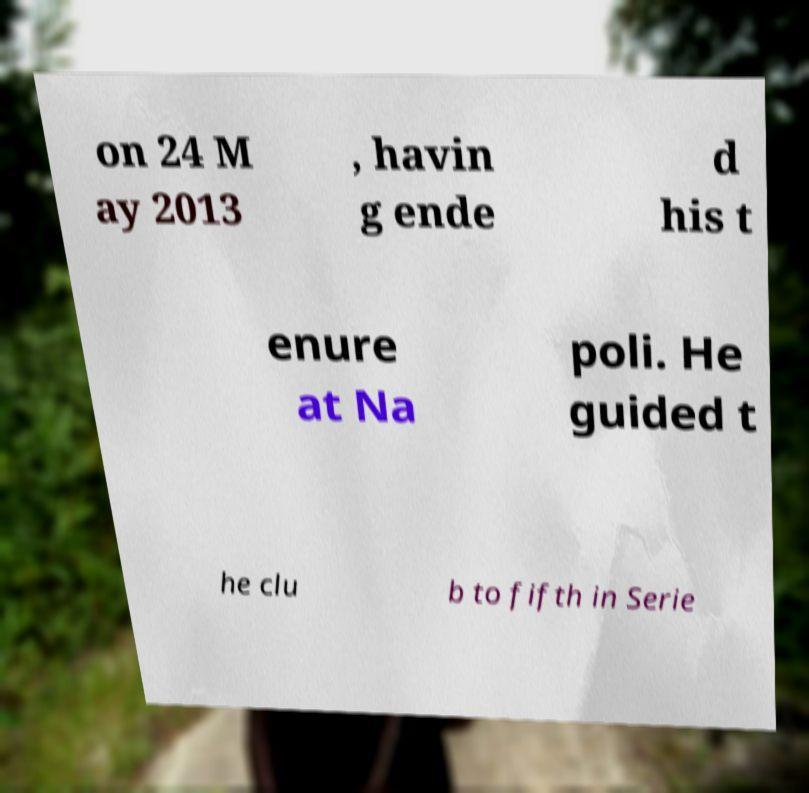Can you read and provide the text displayed in the image?This photo seems to have some interesting text. Can you extract and type it out for me? on 24 M ay 2013 , havin g ende d his t enure at Na poli. He guided t he clu b to fifth in Serie 